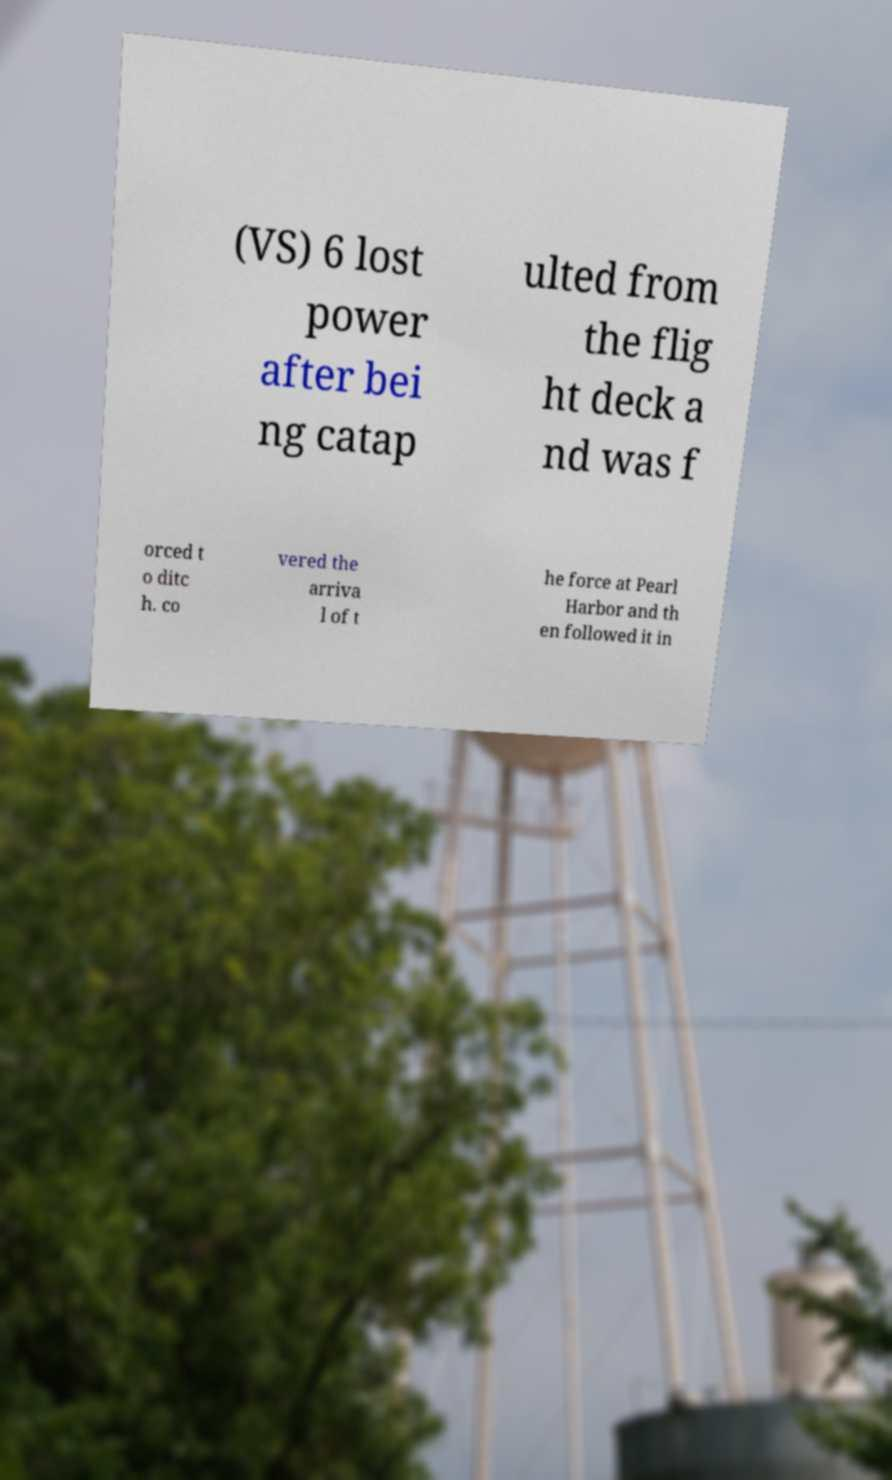What messages or text are displayed in this image? I need them in a readable, typed format. (VS) 6 lost power after bei ng catap ulted from the flig ht deck a nd was f orced t o ditc h. co vered the arriva l of t he force at Pearl Harbor and th en followed it in 